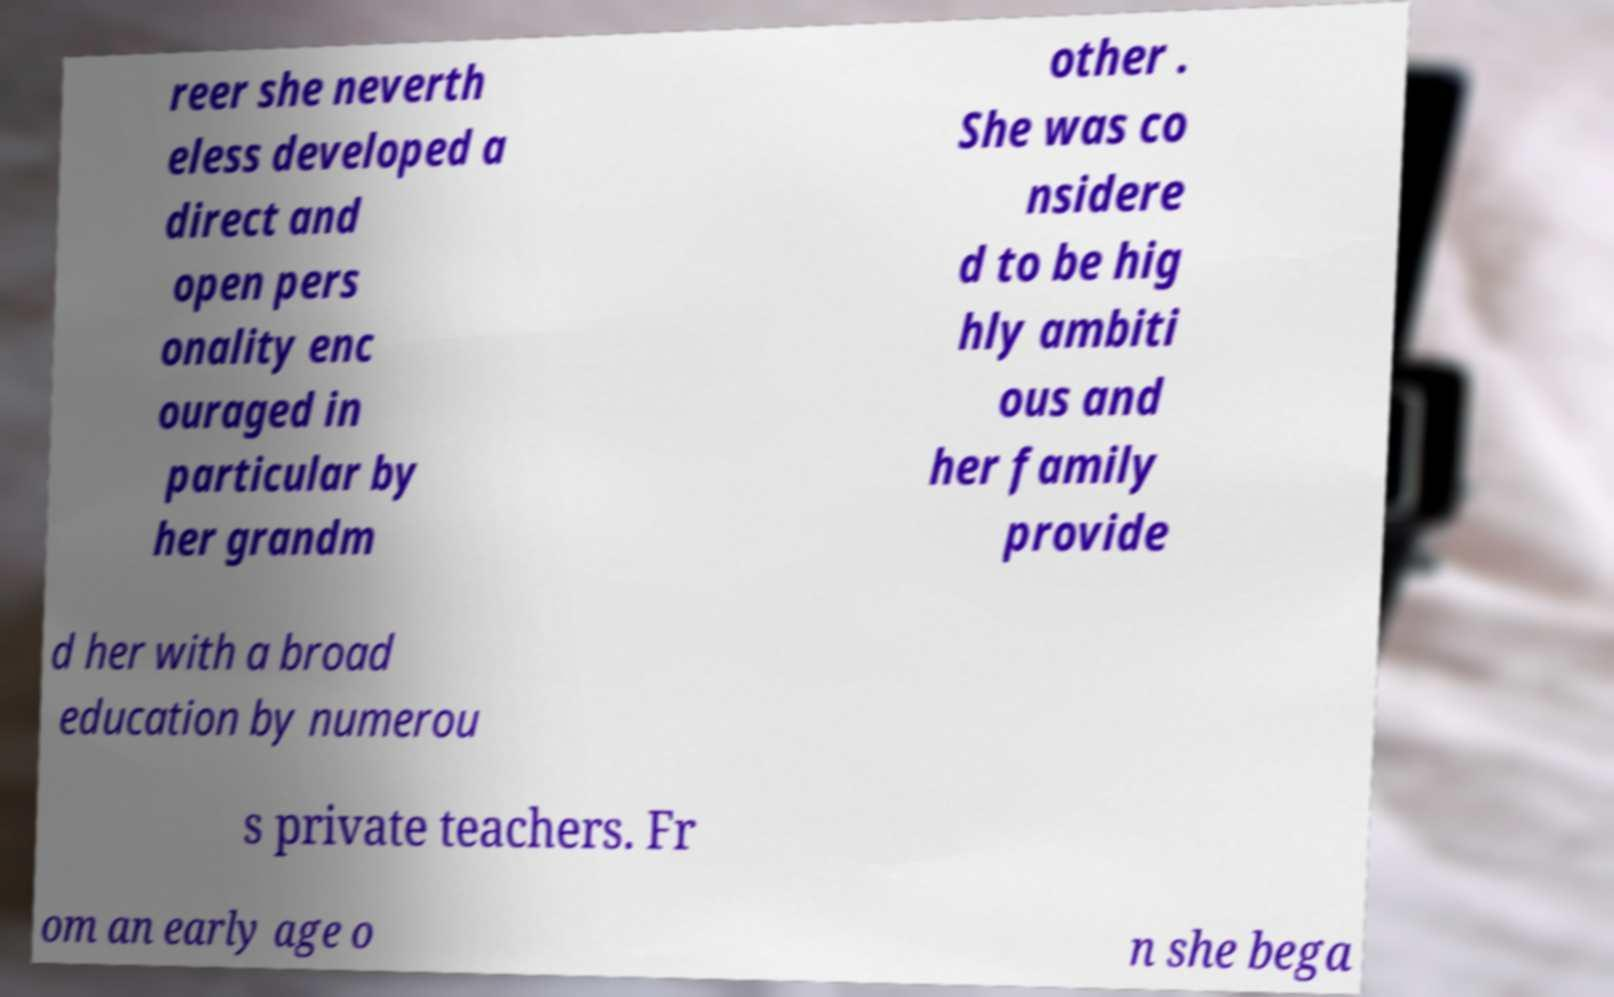Can you read and provide the text displayed in the image?This photo seems to have some interesting text. Can you extract and type it out for me? reer she neverth eless developed a direct and open pers onality enc ouraged in particular by her grandm other . She was co nsidere d to be hig hly ambiti ous and her family provide d her with a broad education by numerou s private teachers. Fr om an early age o n she bega 